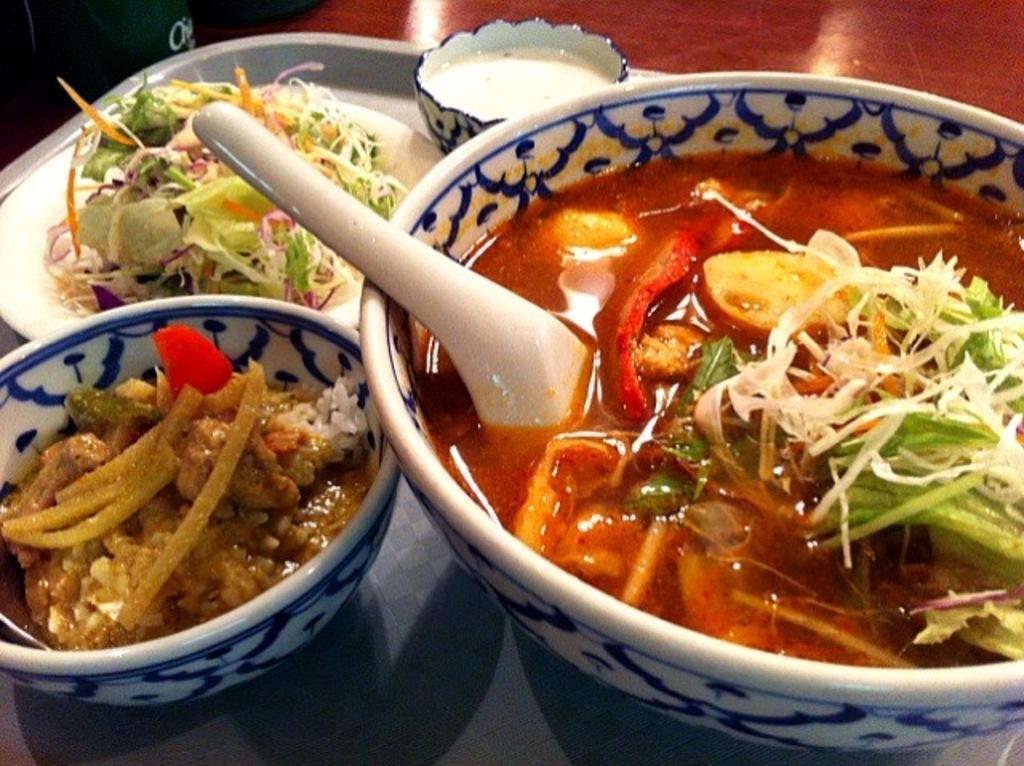Could you give a brief overview of what you see in this image? Above the tree we can see plate, bowls, spoon and food. At the top of the image it is in brown color. 